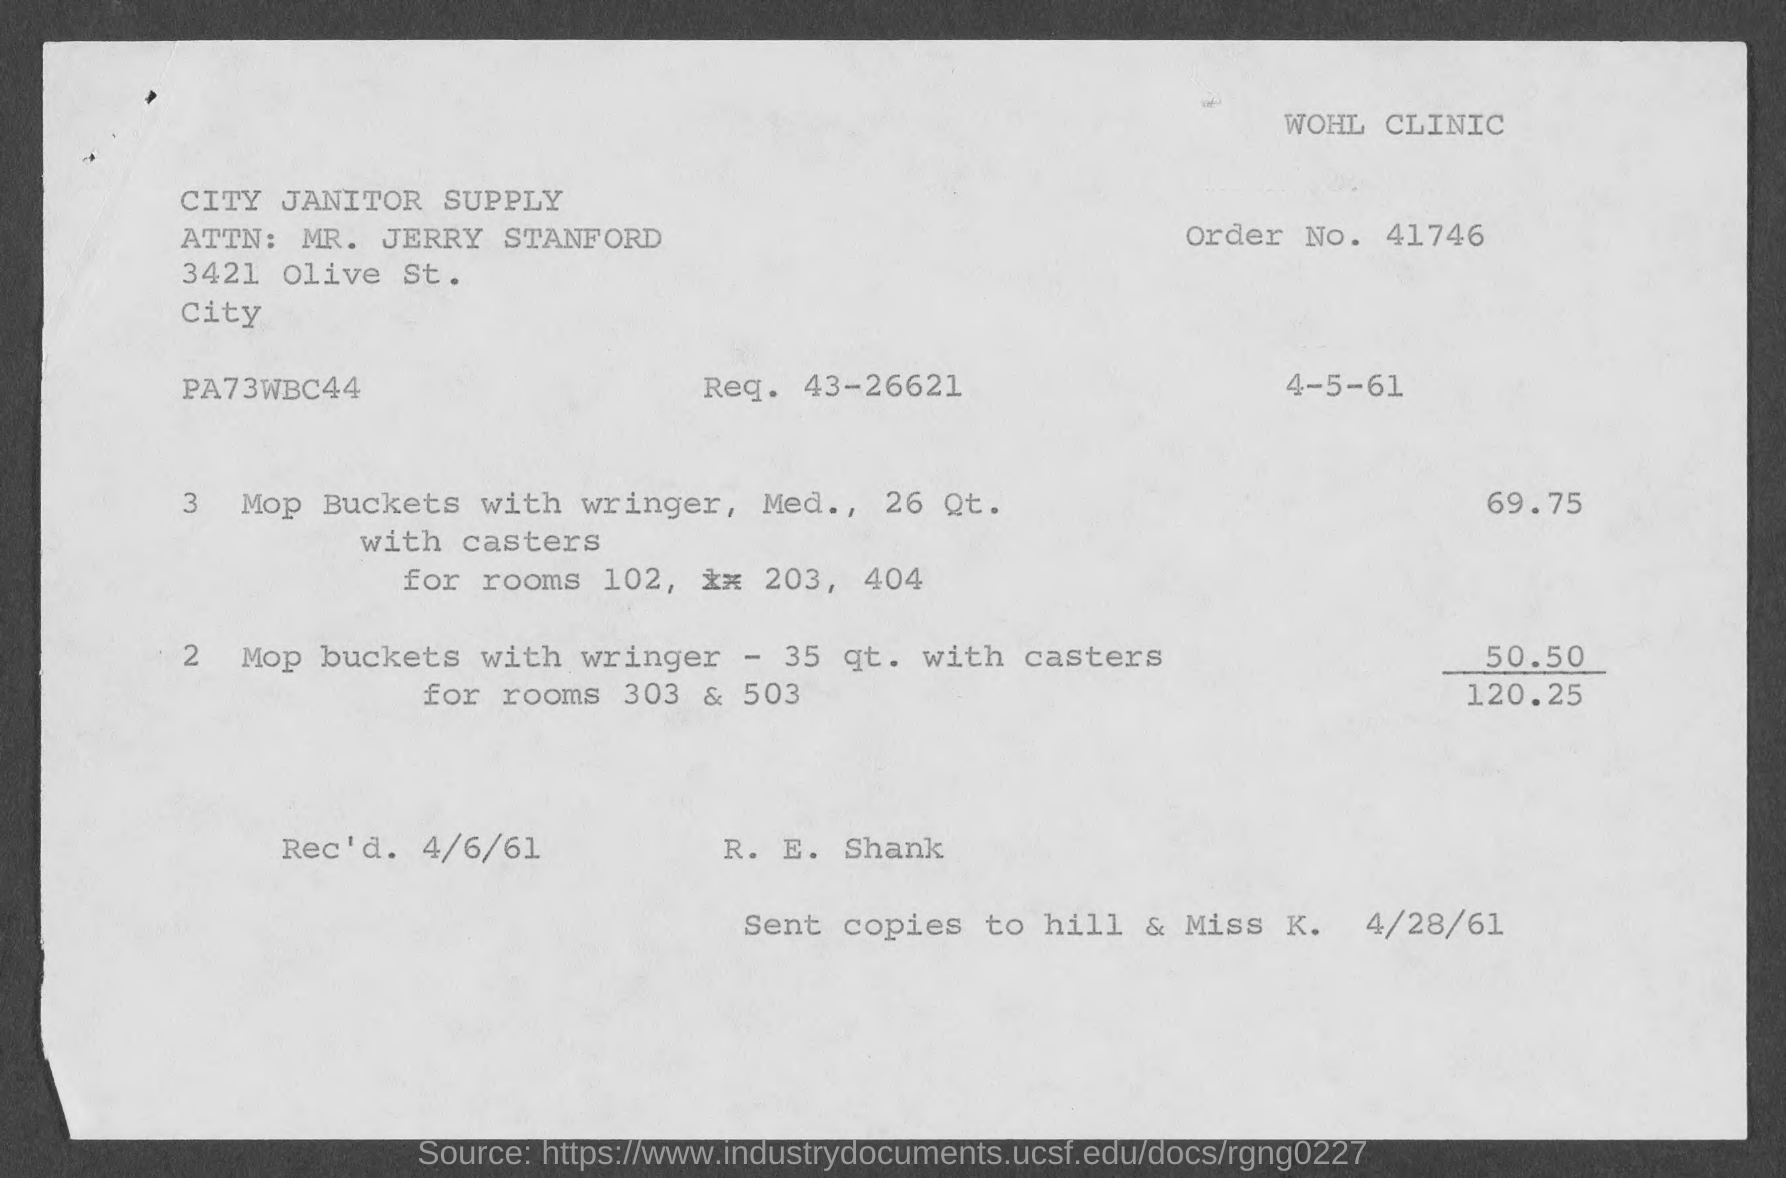List a handful of essential elements in this visual. The request number indicated on the invoice is 43-26621. The invoice indicates that the received date is 4/6/61. The total invoice amount mentioned in the document is 120.25. The order number provided in the invoice is 41746... 